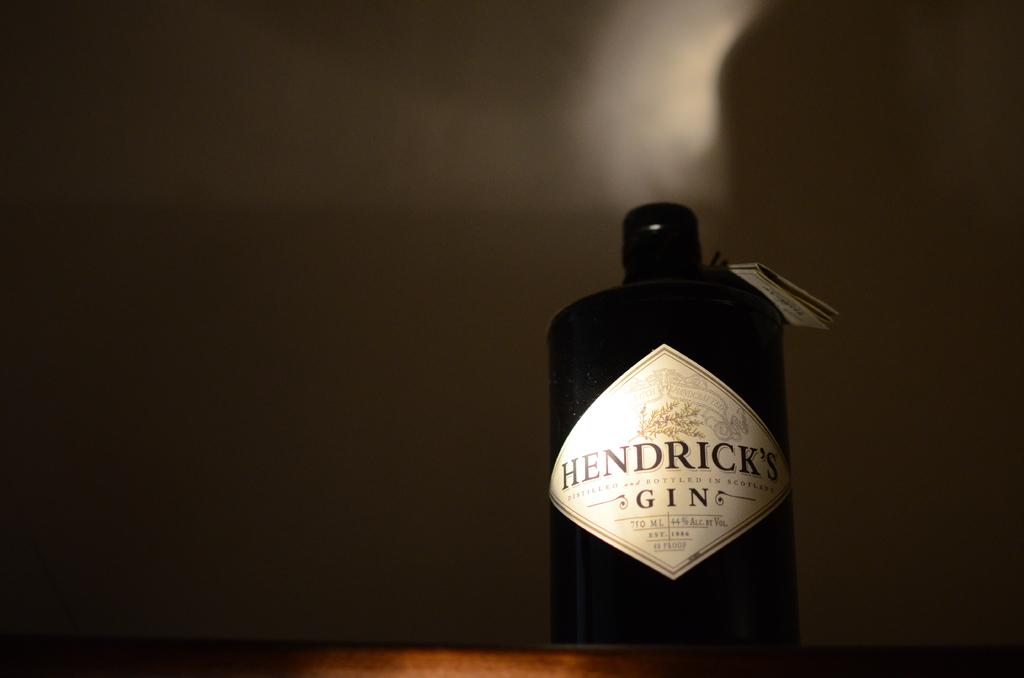What object can be seen in the image? There is a bottle in the image. What is the color of the bottle? The bottle is black in color. Is there any text or design on the bottle? Yes, there is a label on the bottle. What is the bottle placed on? The bottle is placed on a wooden surface. How would you describe the overall lighting or brightness in the image? The background of the image is dark. Can you see any steam coming from the bottle in the image? There is no steam visible in the image, as it features a bottle with a label on a wooden surface. Is the bottle's uncle present in the image? There is no reference to an uncle or any people in the image, only a bottle with a label on a wooden surface. 